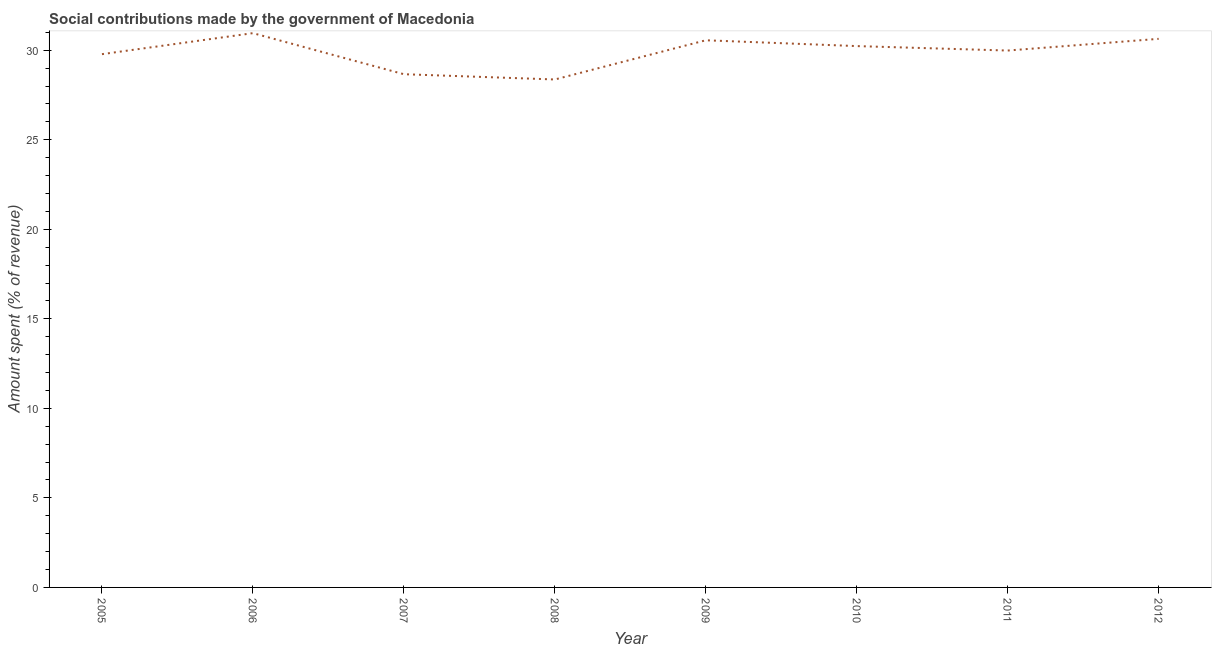What is the amount spent in making social contributions in 2009?
Keep it short and to the point. 30.56. Across all years, what is the maximum amount spent in making social contributions?
Offer a very short reply. 30.96. Across all years, what is the minimum amount spent in making social contributions?
Give a very brief answer. 28.37. What is the sum of the amount spent in making social contributions?
Your answer should be compact. 239.18. What is the difference between the amount spent in making social contributions in 2009 and 2010?
Provide a succinct answer. 0.32. What is the average amount spent in making social contributions per year?
Make the answer very short. 29.9. What is the median amount spent in making social contributions?
Offer a very short reply. 30.11. What is the ratio of the amount spent in making social contributions in 2006 to that in 2011?
Keep it short and to the point. 1.03. Is the amount spent in making social contributions in 2006 less than that in 2009?
Provide a short and direct response. No. Is the difference between the amount spent in making social contributions in 2007 and 2012 greater than the difference between any two years?
Your response must be concise. No. What is the difference between the highest and the second highest amount spent in making social contributions?
Provide a succinct answer. 0.32. Is the sum of the amount spent in making social contributions in 2007 and 2009 greater than the maximum amount spent in making social contributions across all years?
Provide a short and direct response. Yes. What is the difference between the highest and the lowest amount spent in making social contributions?
Your answer should be compact. 2.59. In how many years, is the amount spent in making social contributions greater than the average amount spent in making social contributions taken over all years?
Offer a terse response. 5. Does the amount spent in making social contributions monotonically increase over the years?
Your answer should be very brief. No. How many lines are there?
Offer a very short reply. 1. How many years are there in the graph?
Ensure brevity in your answer.  8. Are the values on the major ticks of Y-axis written in scientific E-notation?
Give a very brief answer. No. What is the title of the graph?
Your answer should be very brief. Social contributions made by the government of Macedonia. What is the label or title of the X-axis?
Offer a very short reply. Year. What is the label or title of the Y-axis?
Ensure brevity in your answer.  Amount spent (% of revenue). What is the Amount spent (% of revenue) of 2005?
Your answer should be compact. 29.78. What is the Amount spent (% of revenue) in 2006?
Offer a very short reply. 30.96. What is the Amount spent (% of revenue) in 2007?
Make the answer very short. 28.66. What is the Amount spent (% of revenue) in 2008?
Make the answer very short. 28.37. What is the Amount spent (% of revenue) in 2009?
Provide a short and direct response. 30.56. What is the Amount spent (% of revenue) in 2010?
Your response must be concise. 30.23. What is the Amount spent (% of revenue) in 2011?
Make the answer very short. 29.98. What is the Amount spent (% of revenue) in 2012?
Your answer should be compact. 30.64. What is the difference between the Amount spent (% of revenue) in 2005 and 2006?
Offer a very short reply. -1.17. What is the difference between the Amount spent (% of revenue) in 2005 and 2007?
Offer a terse response. 1.12. What is the difference between the Amount spent (% of revenue) in 2005 and 2008?
Provide a short and direct response. 1.41. What is the difference between the Amount spent (% of revenue) in 2005 and 2009?
Ensure brevity in your answer.  -0.78. What is the difference between the Amount spent (% of revenue) in 2005 and 2010?
Your response must be concise. -0.45. What is the difference between the Amount spent (% of revenue) in 2005 and 2011?
Give a very brief answer. -0.2. What is the difference between the Amount spent (% of revenue) in 2005 and 2012?
Give a very brief answer. -0.86. What is the difference between the Amount spent (% of revenue) in 2006 and 2007?
Your response must be concise. 2.29. What is the difference between the Amount spent (% of revenue) in 2006 and 2008?
Your response must be concise. 2.59. What is the difference between the Amount spent (% of revenue) in 2006 and 2009?
Give a very brief answer. 0.4. What is the difference between the Amount spent (% of revenue) in 2006 and 2010?
Provide a succinct answer. 0.72. What is the difference between the Amount spent (% of revenue) in 2006 and 2011?
Give a very brief answer. 0.97. What is the difference between the Amount spent (% of revenue) in 2006 and 2012?
Offer a very short reply. 0.32. What is the difference between the Amount spent (% of revenue) in 2007 and 2008?
Give a very brief answer. 0.29. What is the difference between the Amount spent (% of revenue) in 2007 and 2009?
Give a very brief answer. -1.9. What is the difference between the Amount spent (% of revenue) in 2007 and 2010?
Provide a succinct answer. -1.57. What is the difference between the Amount spent (% of revenue) in 2007 and 2011?
Provide a short and direct response. -1.32. What is the difference between the Amount spent (% of revenue) in 2007 and 2012?
Make the answer very short. -1.98. What is the difference between the Amount spent (% of revenue) in 2008 and 2009?
Ensure brevity in your answer.  -2.19. What is the difference between the Amount spent (% of revenue) in 2008 and 2010?
Make the answer very short. -1.86. What is the difference between the Amount spent (% of revenue) in 2008 and 2011?
Ensure brevity in your answer.  -1.62. What is the difference between the Amount spent (% of revenue) in 2008 and 2012?
Provide a succinct answer. -2.27. What is the difference between the Amount spent (% of revenue) in 2009 and 2010?
Keep it short and to the point. 0.32. What is the difference between the Amount spent (% of revenue) in 2009 and 2011?
Your answer should be compact. 0.57. What is the difference between the Amount spent (% of revenue) in 2009 and 2012?
Offer a terse response. -0.08. What is the difference between the Amount spent (% of revenue) in 2010 and 2011?
Ensure brevity in your answer.  0.25. What is the difference between the Amount spent (% of revenue) in 2010 and 2012?
Make the answer very short. -0.41. What is the difference between the Amount spent (% of revenue) in 2011 and 2012?
Provide a short and direct response. -0.65. What is the ratio of the Amount spent (% of revenue) in 2005 to that in 2007?
Your response must be concise. 1.04. What is the ratio of the Amount spent (% of revenue) in 2005 to that in 2009?
Ensure brevity in your answer.  0.97. What is the ratio of the Amount spent (% of revenue) in 2005 to that in 2011?
Your answer should be very brief. 0.99. What is the ratio of the Amount spent (% of revenue) in 2006 to that in 2007?
Give a very brief answer. 1.08. What is the ratio of the Amount spent (% of revenue) in 2006 to that in 2008?
Keep it short and to the point. 1.09. What is the ratio of the Amount spent (% of revenue) in 2006 to that in 2009?
Give a very brief answer. 1.01. What is the ratio of the Amount spent (% of revenue) in 2006 to that in 2011?
Offer a very short reply. 1.03. What is the ratio of the Amount spent (% of revenue) in 2006 to that in 2012?
Provide a short and direct response. 1.01. What is the ratio of the Amount spent (% of revenue) in 2007 to that in 2008?
Your answer should be compact. 1.01. What is the ratio of the Amount spent (% of revenue) in 2007 to that in 2009?
Your answer should be very brief. 0.94. What is the ratio of the Amount spent (% of revenue) in 2007 to that in 2010?
Your answer should be compact. 0.95. What is the ratio of the Amount spent (% of revenue) in 2007 to that in 2011?
Your response must be concise. 0.96. What is the ratio of the Amount spent (% of revenue) in 2007 to that in 2012?
Offer a very short reply. 0.94. What is the ratio of the Amount spent (% of revenue) in 2008 to that in 2009?
Offer a very short reply. 0.93. What is the ratio of the Amount spent (% of revenue) in 2008 to that in 2010?
Make the answer very short. 0.94. What is the ratio of the Amount spent (% of revenue) in 2008 to that in 2011?
Your response must be concise. 0.95. What is the ratio of the Amount spent (% of revenue) in 2008 to that in 2012?
Provide a succinct answer. 0.93. What is the ratio of the Amount spent (% of revenue) in 2009 to that in 2010?
Keep it short and to the point. 1.01. What is the ratio of the Amount spent (% of revenue) in 2009 to that in 2011?
Offer a terse response. 1.02. What is the ratio of the Amount spent (% of revenue) in 2010 to that in 2011?
Give a very brief answer. 1.01. What is the ratio of the Amount spent (% of revenue) in 2010 to that in 2012?
Offer a very short reply. 0.99. 